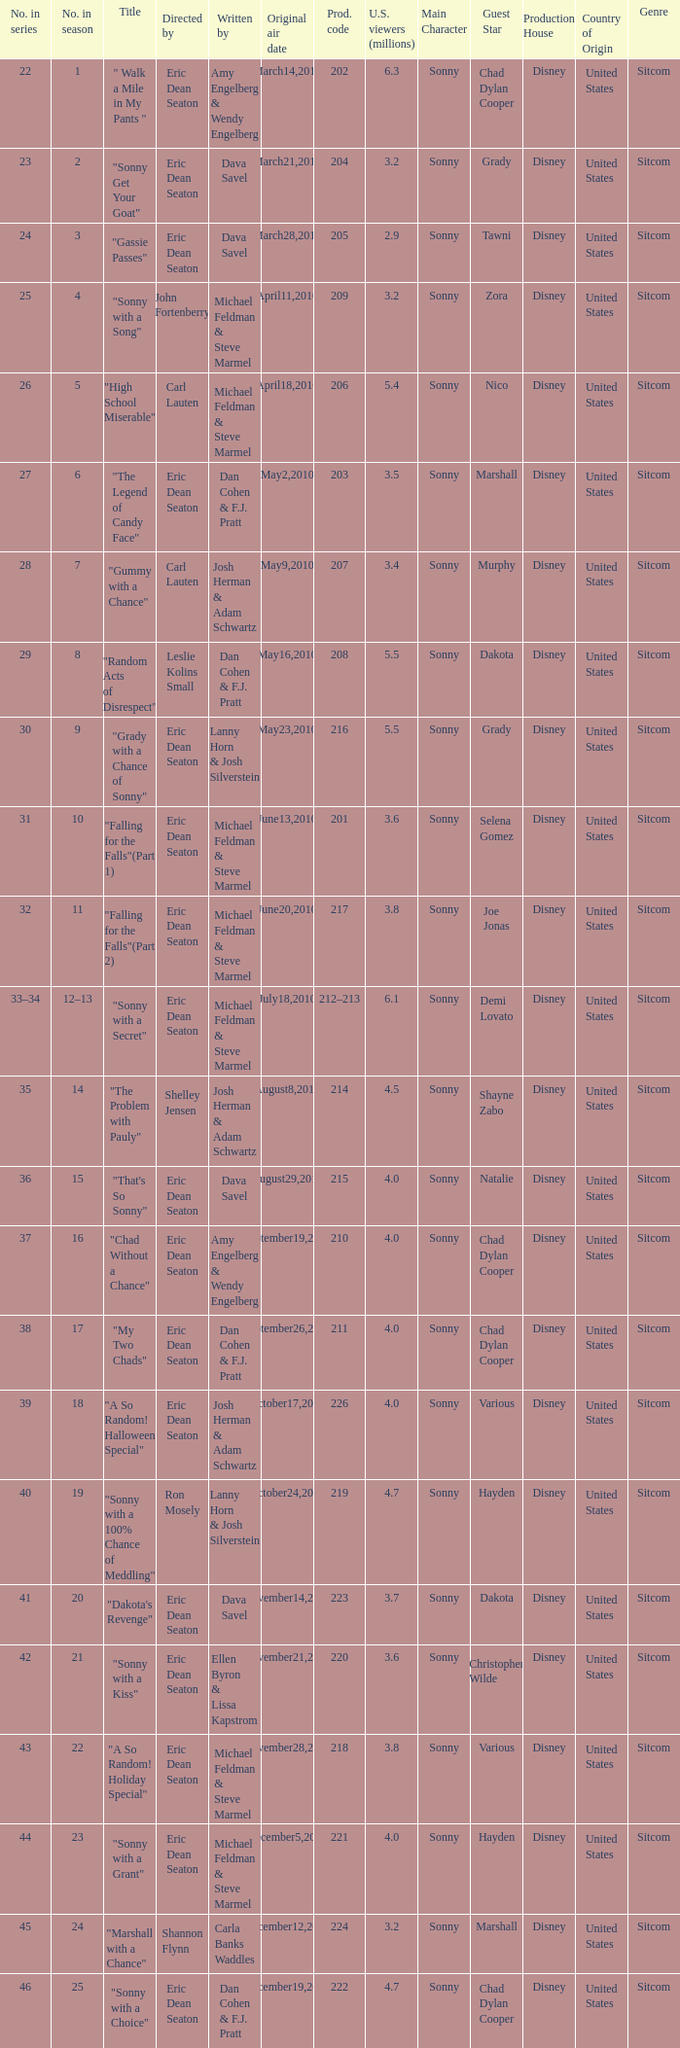How man episodes in the season were titled "that's so sonny"? 1.0. 